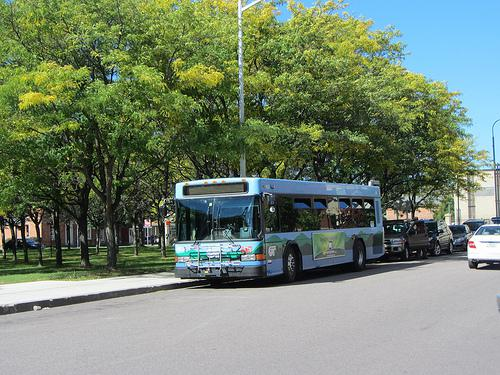Question: what color are the trees?
Choices:
A. Teal.
B. Green.
C. Purple.
D. Neon.
Answer with the letter. Answer: B Question: what color is the bus?
Choices:
A. Teal.
B. White and blue.
C. Purple.
D. Neon.
Answer with the letter. Answer: B Question: what is in the background?
Choices:
A. Cars.
B. People.
C. Boats.
D. Trees.
Answer with the letter. Answer: D Question: where is the bus?
Choices:
A. In the garage.
B. 5 miles away.
C. Heading to Dallas.
D. Curbside.
Answer with the letter. Answer: D 